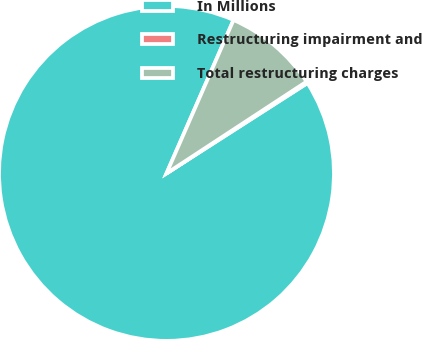Convert chart to OTSL. <chart><loc_0><loc_0><loc_500><loc_500><pie_chart><fcel>In Millions<fcel>Restructuring impairment and<fcel>Total restructuring charges<nl><fcel>90.63%<fcel>0.16%<fcel>9.21%<nl></chart> 